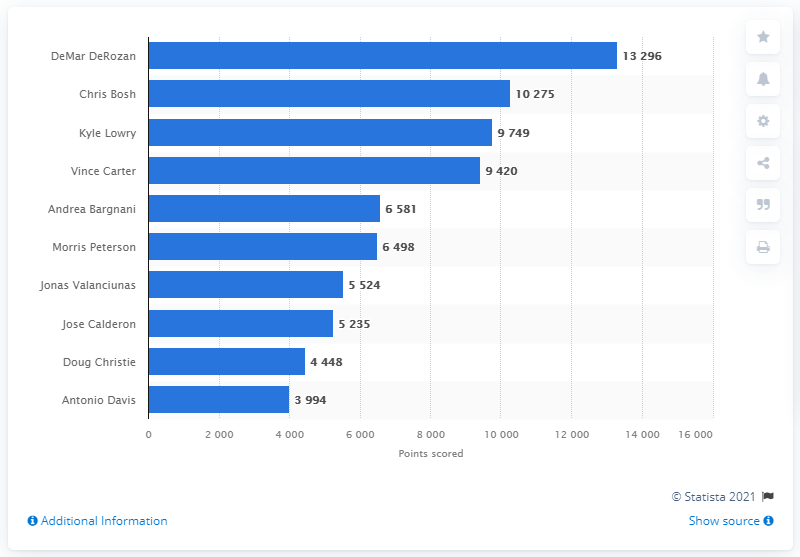Highlight a few significant elements in this photo. DeMar DeRozan is the career points leader of the Toronto Raptors. 